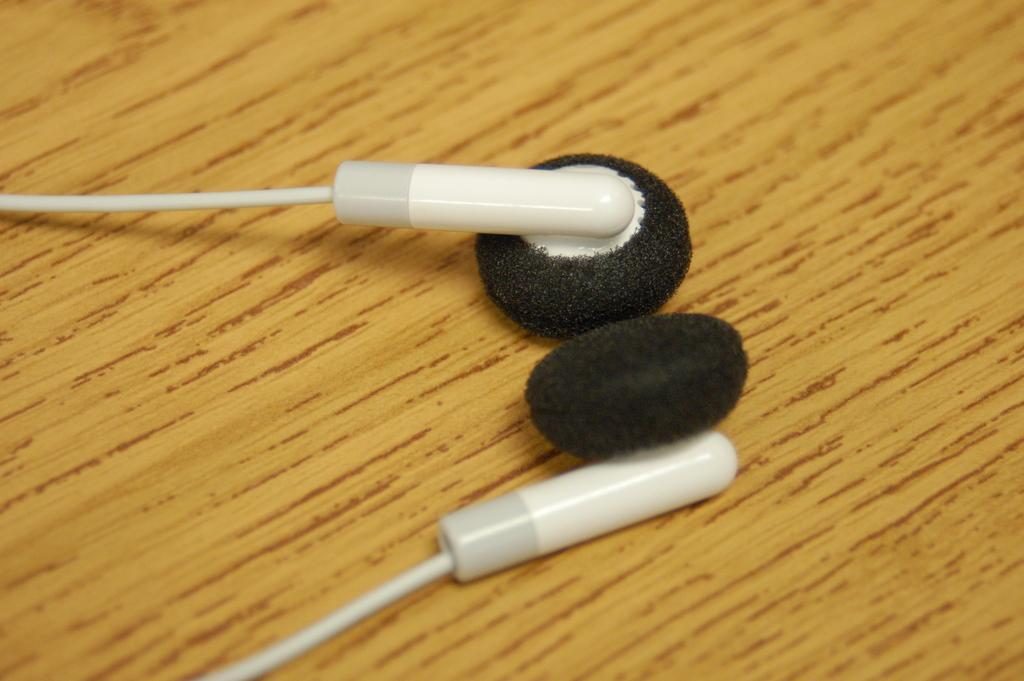How would you summarize this image in a sentence or two? In this image we can see a pair of earphones placed on the wooden surface. 